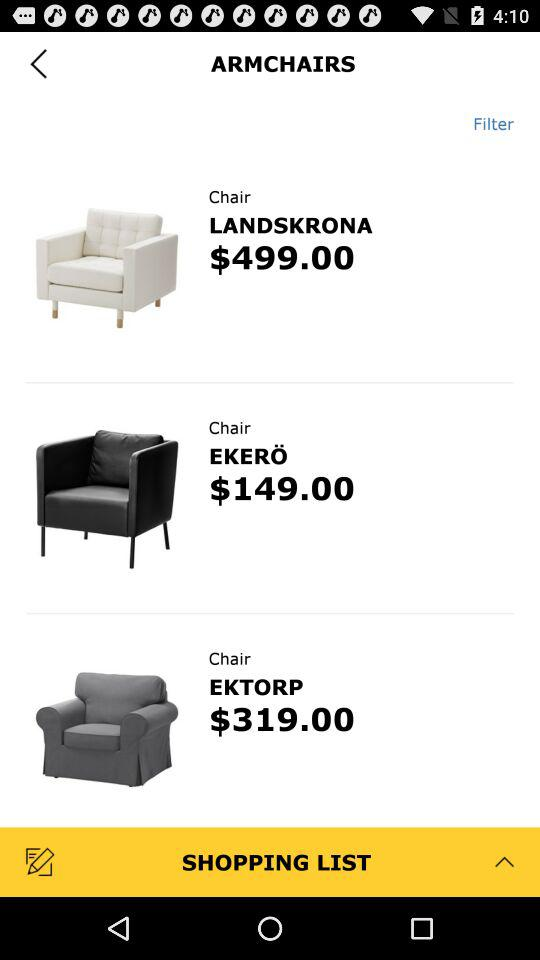Which chair is priced at $319.00? The chair that is priced at $319 is "EKTORP". 